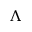Convert formula to latex. <formula><loc_0><loc_0><loc_500><loc_500>\Lambda</formula> 